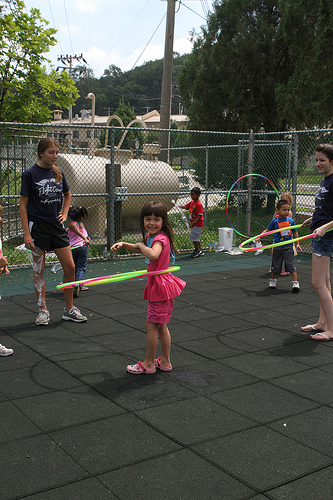<image>
Can you confirm if the shoe is next to the hula hoop? No. The shoe is not positioned next to the hula hoop. They are located in different areas of the scene. 